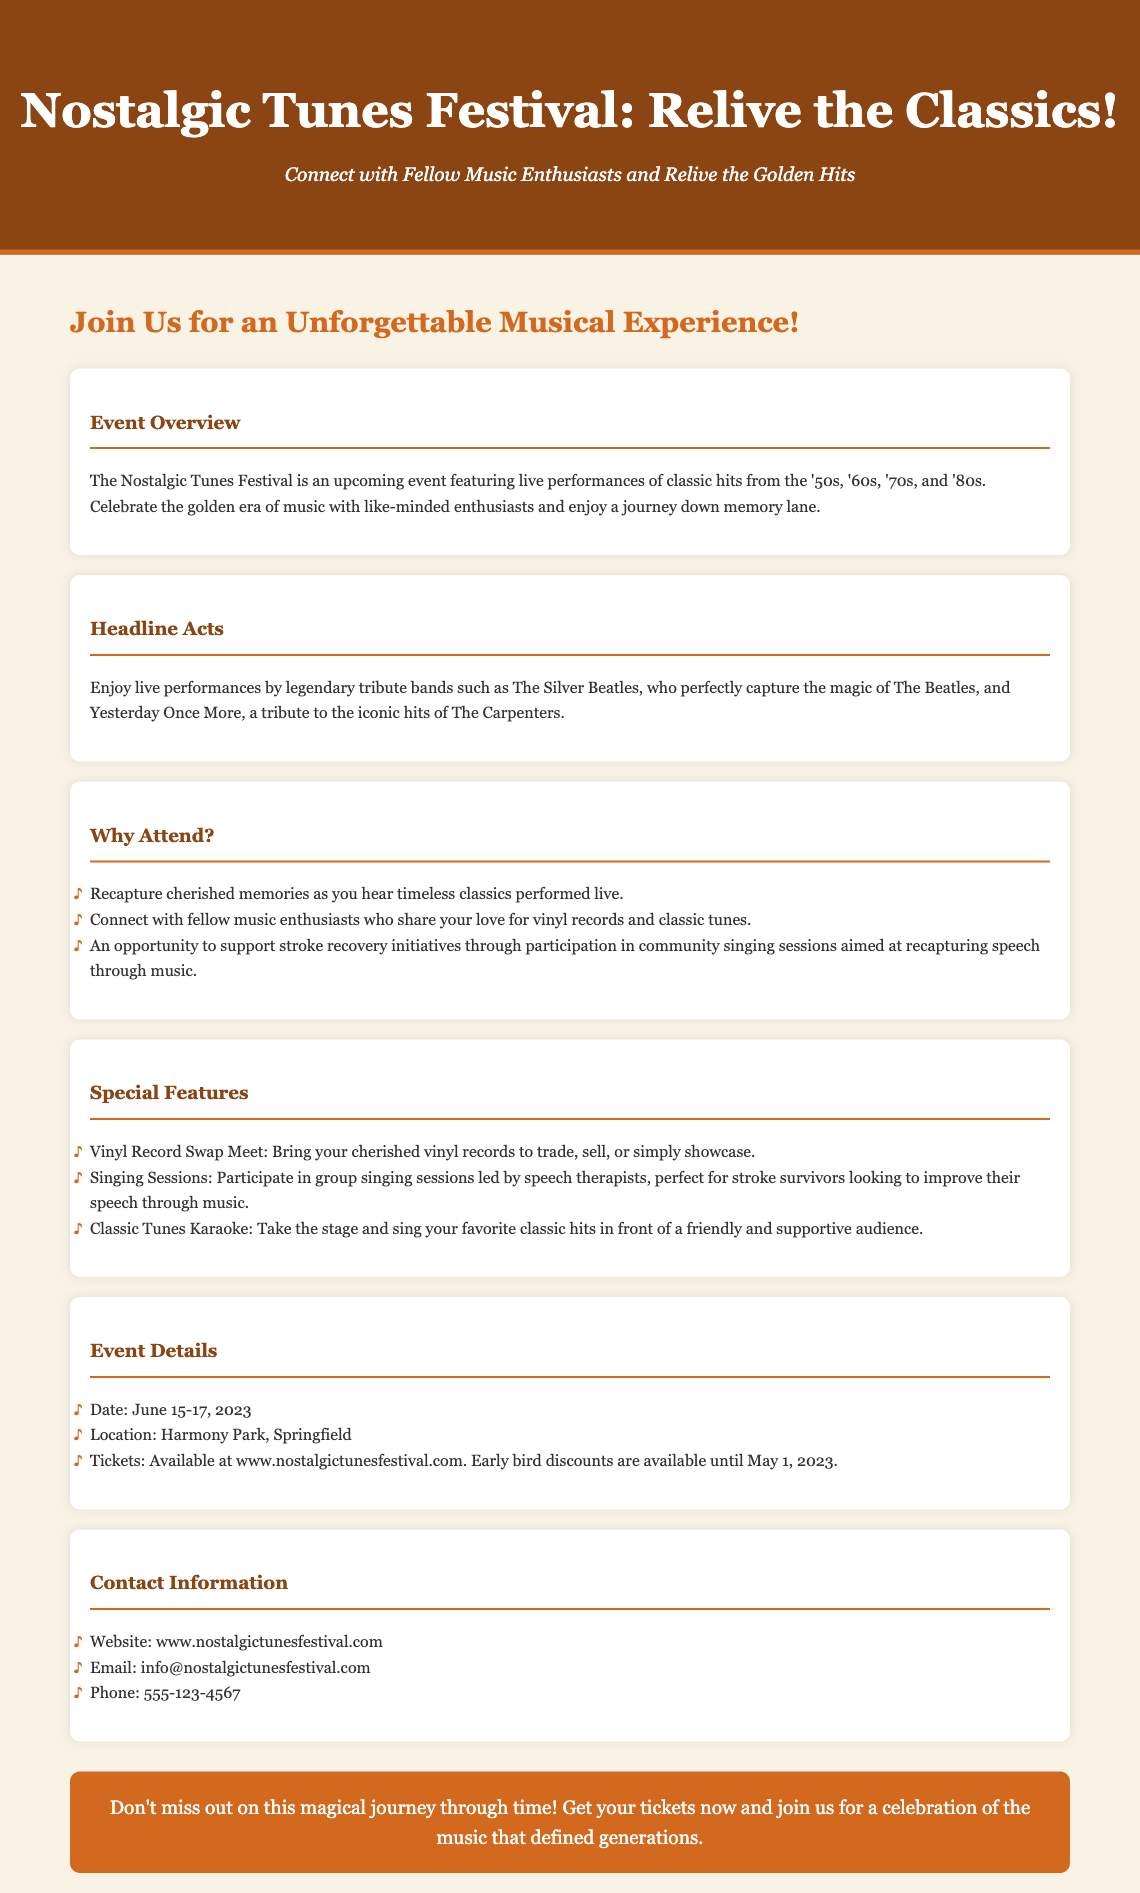What are the dates of the event? The document specifies the event dates as June 15-17, 2023.
Answer: June 15-17, 2023 What is the location of the festival? The location mentioned in the document is Harmony Park, Springfield.
Answer: Harmony Park, Springfield Who are the headline acts? The document lists The Silver Beatles and Yesterday Once More as headline acts.
Answer: The Silver Beatles, Yesterday Once More What is one special feature of the festival? The document highlights the Vinyl Record Swap Meet as one of the special features.
Answer: Vinyl Record Swap Meet What is the purpose of the community singing sessions? The community singing sessions are aimed at supporting stroke recovery initiatives.
Answer: Supporting stroke recovery initiatives What kind of music will be performed at the festival? The festival features classic hits from the '50s, '60s, '70s, and '80s.
Answer: Classic hits from the '50s, '60s, '70s, and '80s What is the website for ticket purchases? The document indicates that tickets can be purchased at www.nostalgictunesfestival.com.
Answer: www.nostalgictunesfestival.com What is offered at the Classic Tunes Karaoke? The Classic Tunes Karaoke allows participants to sing favorite classic hits.
Answer: Sing favorite classic hits 